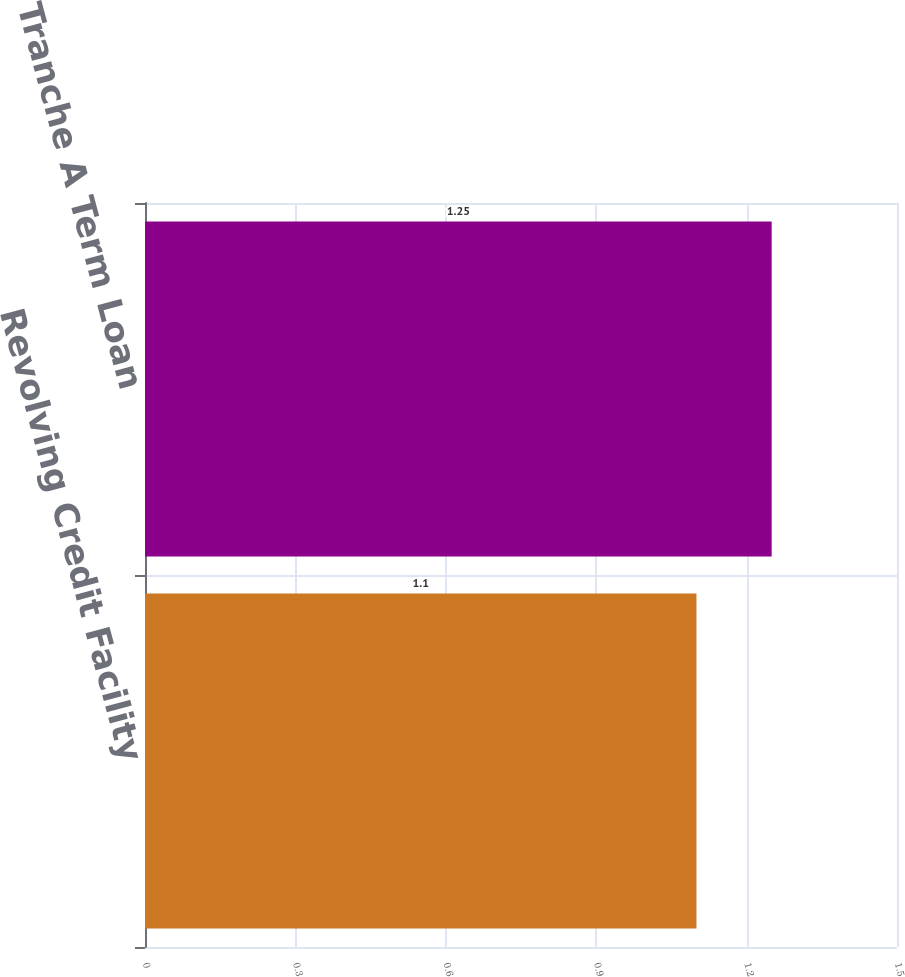Convert chart. <chart><loc_0><loc_0><loc_500><loc_500><bar_chart><fcel>Revolving Credit Facility<fcel>Tranche A Term Loan<nl><fcel>1.1<fcel>1.25<nl></chart> 